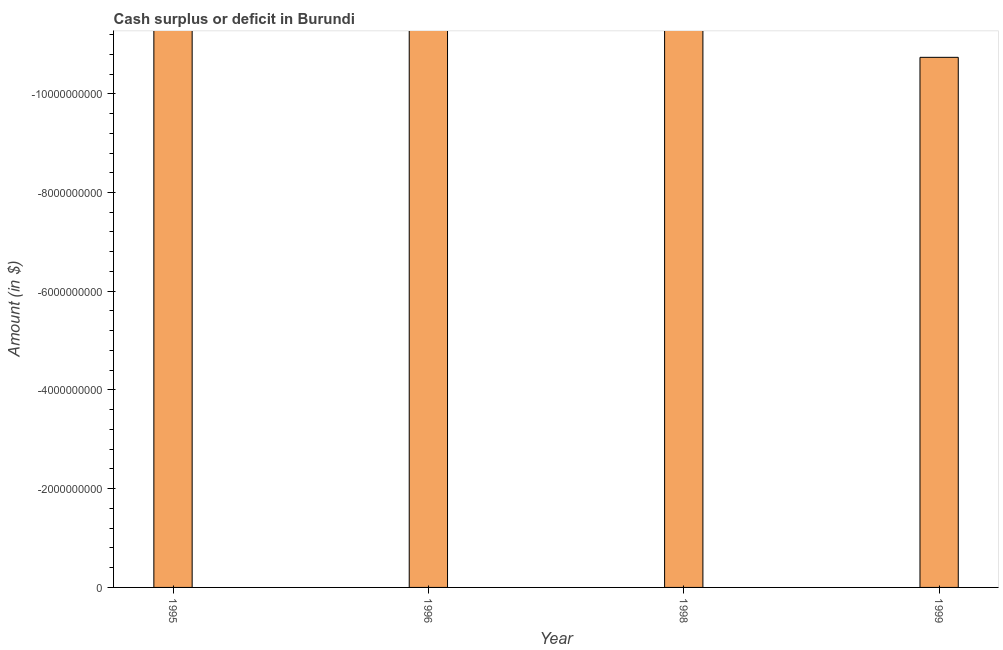Does the graph contain grids?
Your answer should be compact. No. What is the title of the graph?
Ensure brevity in your answer.  Cash surplus or deficit in Burundi. What is the label or title of the Y-axis?
Offer a terse response. Amount (in $). Across all years, what is the minimum cash surplus or deficit?
Provide a succinct answer. 0. What is the average cash surplus or deficit per year?
Your answer should be very brief. 0. What is the median cash surplus or deficit?
Your answer should be very brief. 0. How many years are there in the graph?
Give a very brief answer. 4. What is the difference between two consecutive major ticks on the Y-axis?
Offer a very short reply. 2.00e+09. What is the Amount (in $) of 1996?
Provide a short and direct response. 0. What is the Amount (in $) in 1998?
Your answer should be compact. 0. What is the Amount (in $) of 1999?
Keep it short and to the point. 0. 